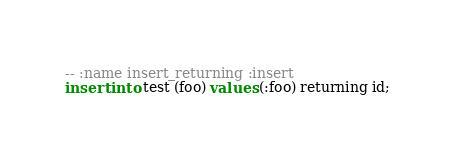<code> <loc_0><loc_0><loc_500><loc_500><_SQL_>-- :name insert_returning :insert
insert into test (foo) values (:foo) returning id;
</code> 